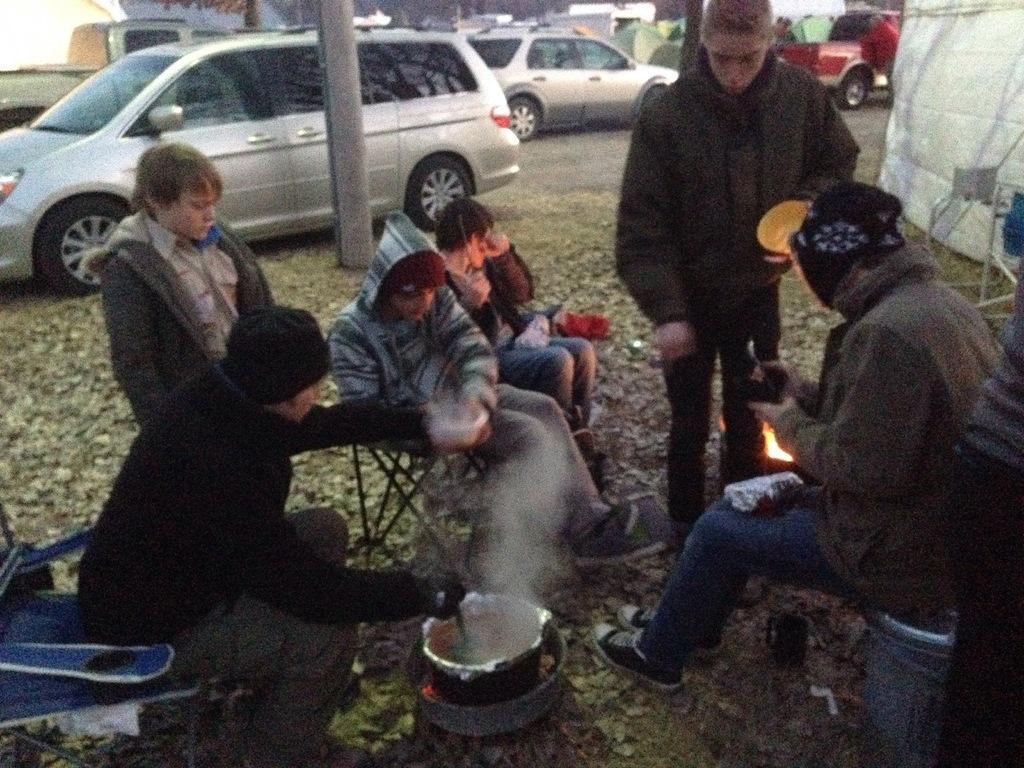Describe this image in one or two sentences. In this image, we can see people wearing clothes. There is a dish at the bottom of the image. There is a pole and some vehicles at the top of the image. There is a chair in the bottom left of the image. 